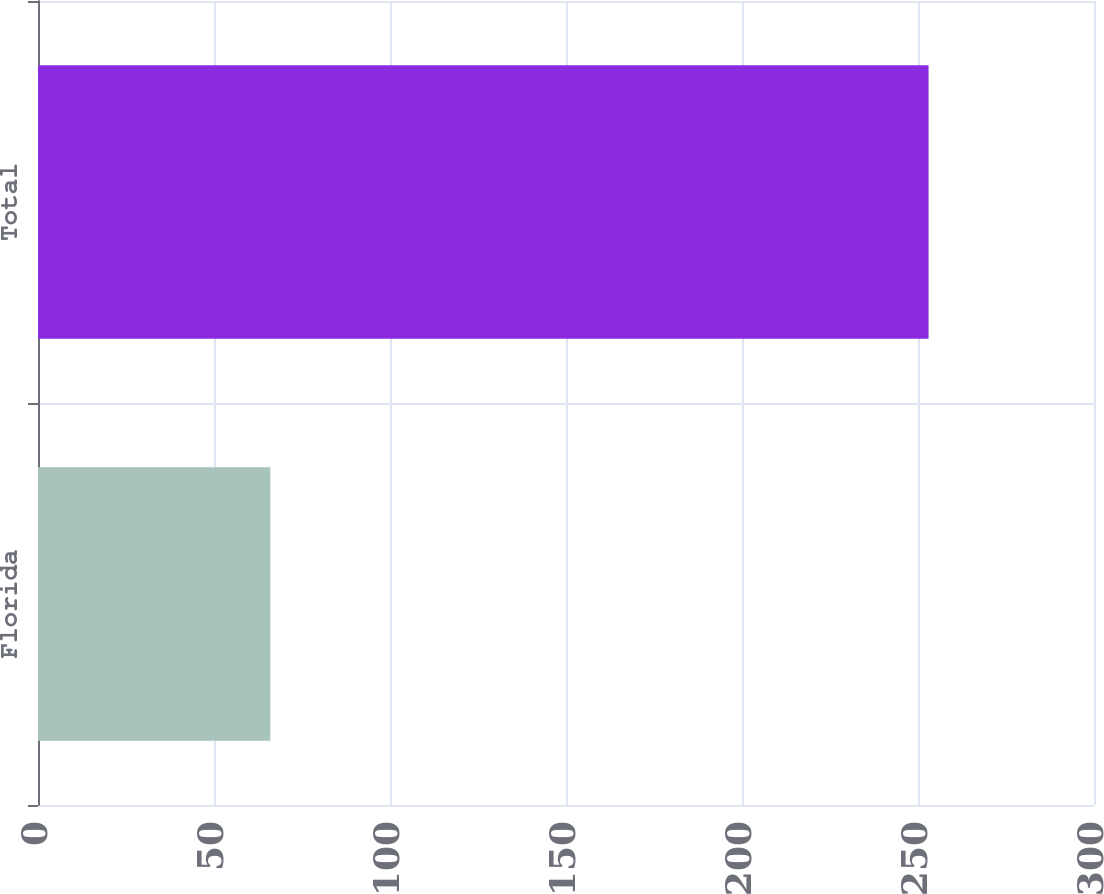<chart> <loc_0><loc_0><loc_500><loc_500><bar_chart><fcel>Florida<fcel>Total<nl><fcel>66<fcel>253<nl></chart> 